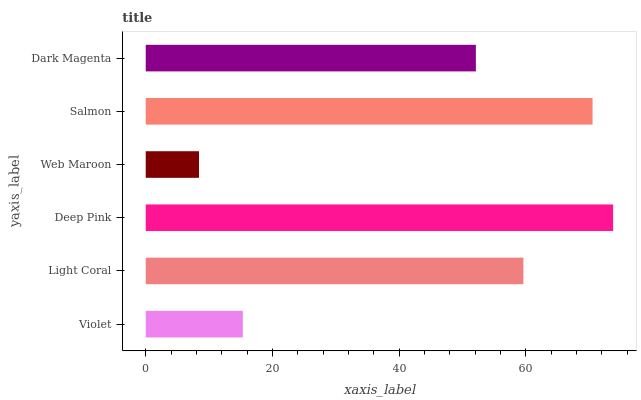Is Web Maroon the minimum?
Answer yes or no. Yes. Is Deep Pink the maximum?
Answer yes or no. Yes. Is Light Coral the minimum?
Answer yes or no. No. Is Light Coral the maximum?
Answer yes or no. No. Is Light Coral greater than Violet?
Answer yes or no. Yes. Is Violet less than Light Coral?
Answer yes or no. Yes. Is Violet greater than Light Coral?
Answer yes or no. No. Is Light Coral less than Violet?
Answer yes or no. No. Is Light Coral the high median?
Answer yes or no. Yes. Is Dark Magenta the low median?
Answer yes or no. Yes. Is Deep Pink the high median?
Answer yes or no. No. Is Light Coral the low median?
Answer yes or no. No. 